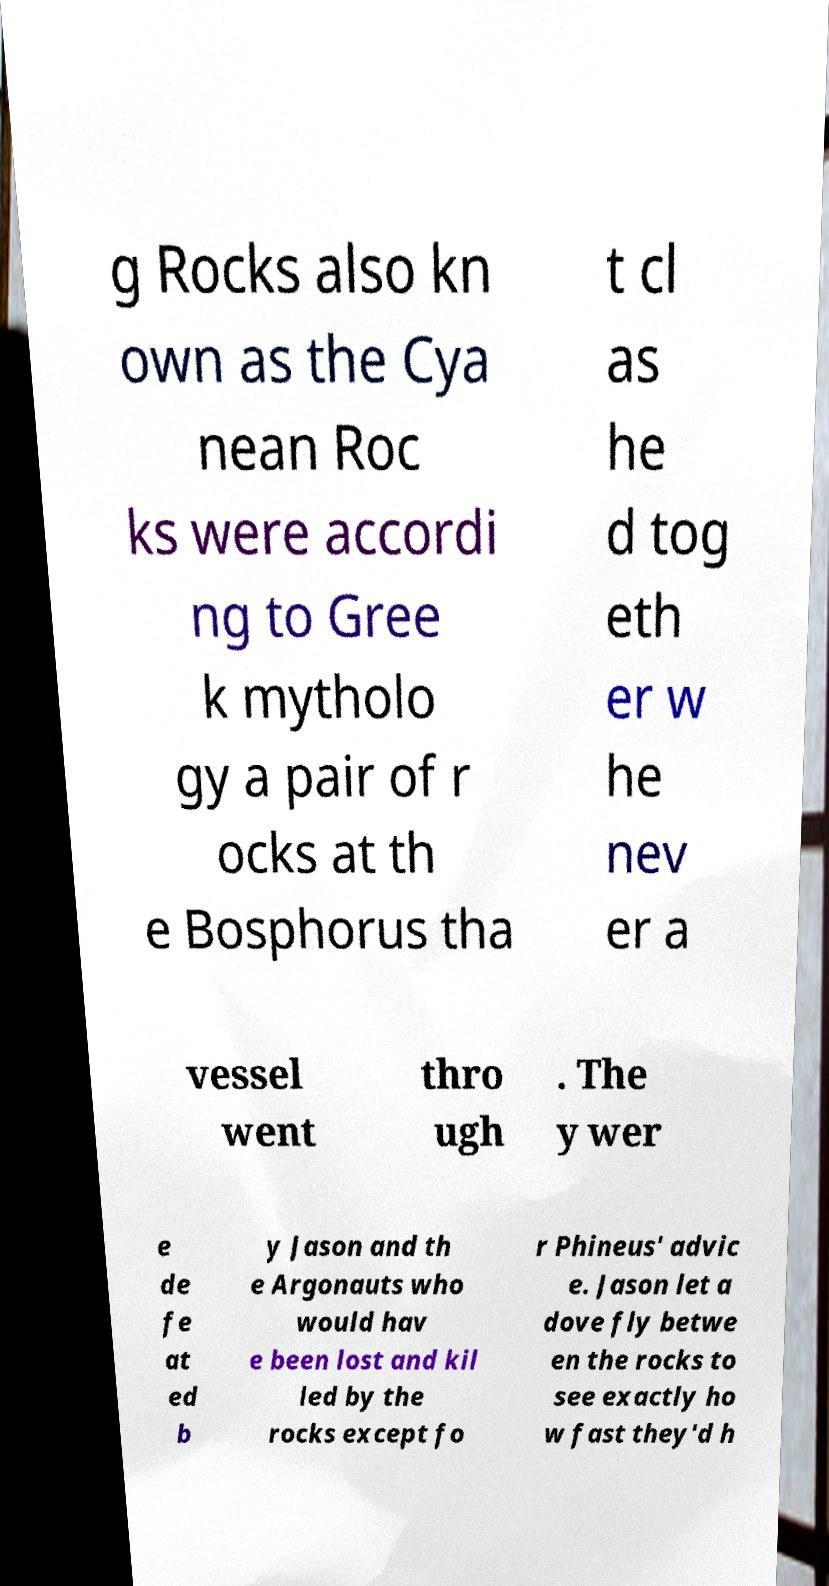Could you extract and type out the text from this image? g Rocks also kn own as the Cya nean Roc ks were accordi ng to Gree k mytholo gy a pair of r ocks at th e Bosphorus tha t cl as he d tog eth er w he nev er a vessel went thro ugh . The y wer e de fe at ed b y Jason and th e Argonauts who would hav e been lost and kil led by the rocks except fo r Phineus' advic e. Jason let a dove fly betwe en the rocks to see exactly ho w fast they'd h 